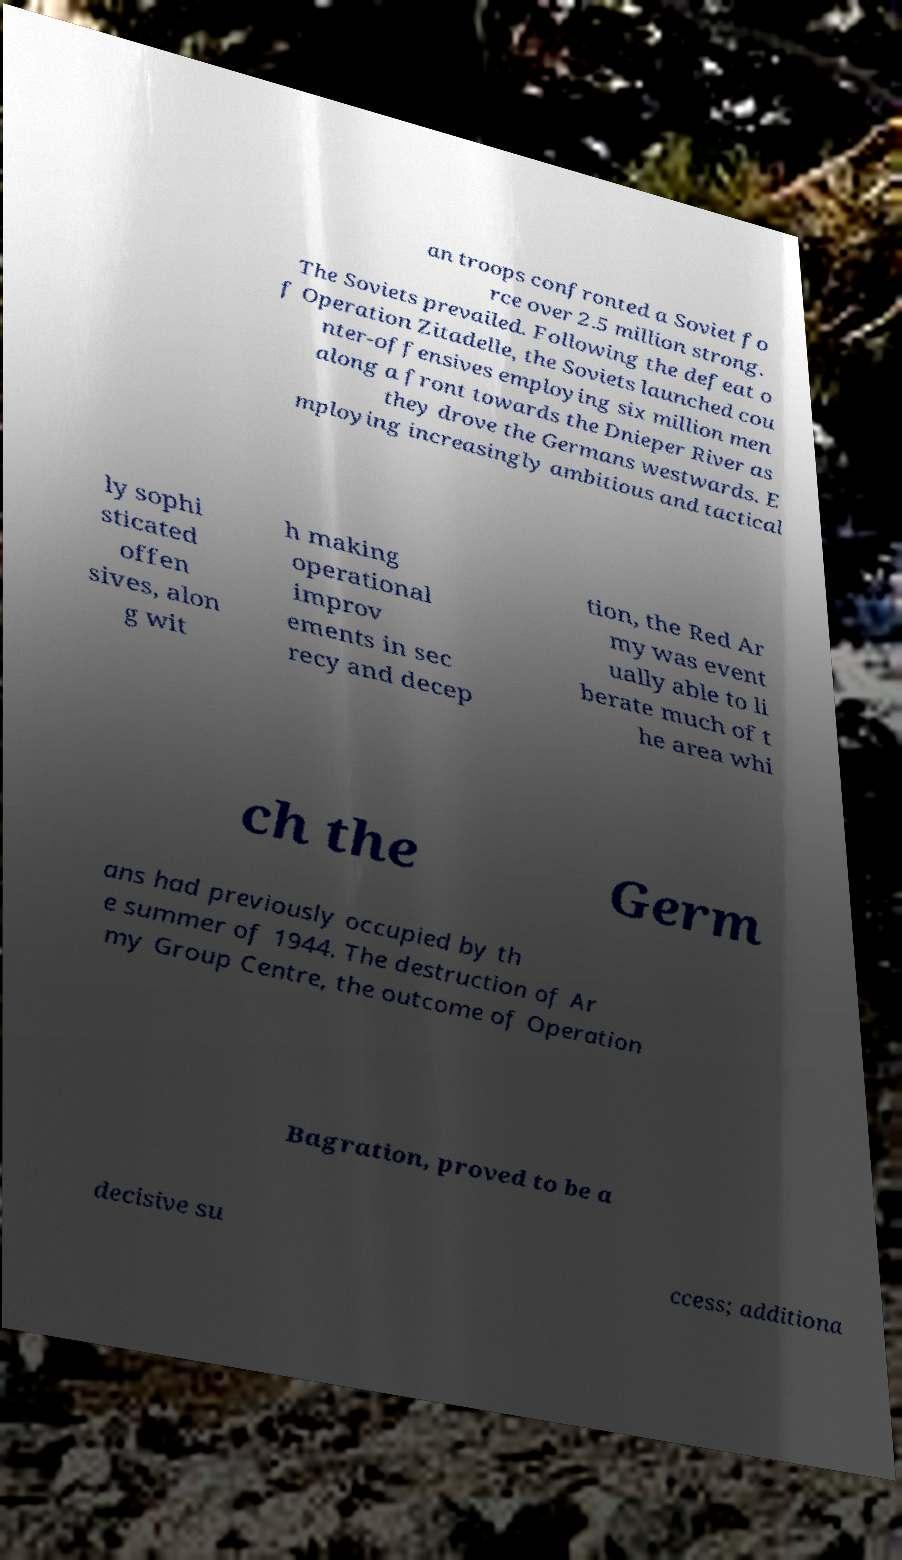For documentation purposes, I need the text within this image transcribed. Could you provide that? an troops confronted a Soviet fo rce over 2.5 million strong. The Soviets prevailed. Following the defeat o f Operation Zitadelle, the Soviets launched cou nter-offensives employing six million men along a front towards the Dnieper River as they drove the Germans westwards. E mploying increasingly ambitious and tactical ly sophi sticated offen sives, alon g wit h making operational improv ements in sec recy and decep tion, the Red Ar my was event ually able to li berate much of t he area whi ch the Germ ans had previously occupied by th e summer of 1944. The destruction of Ar my Group Centre, the outcome of Operation Bagration, proved to be a decisive su ccess; additiona 